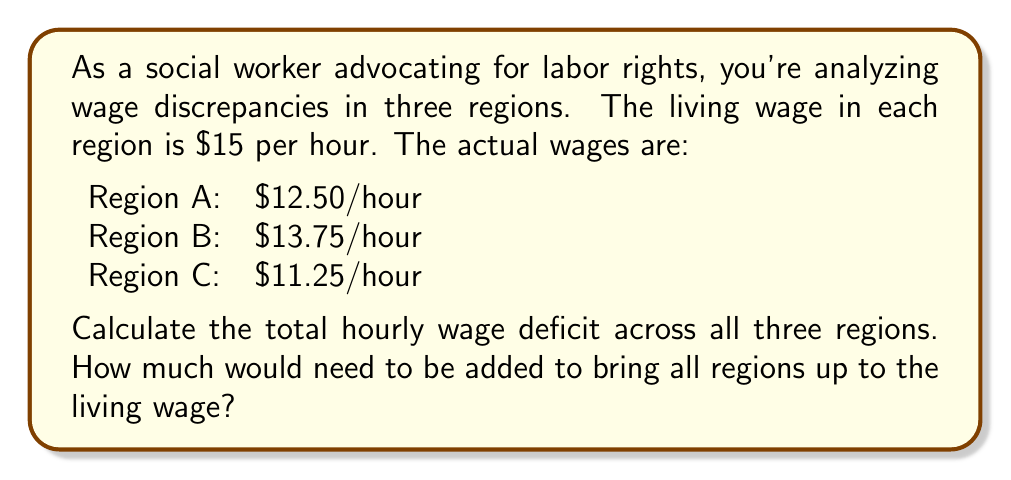Teach me how to tackle this problem. To solve this problem, we need to:
1. Calculate the wage deficit for each region
2. Sum up the deficits to get the total hourly wage deficit

Let's go through each step:

1. Calculating wage deficits:
   Region A: $15 - $12.50 = $2.50/hour
   Region B: $15 - $13.75 = $1.25/hour
   Region C: $15 - $11.25 = $3.75/hour

2. Summing up the deficits:
   Total deficit = Deficit A + Deficit B + Deficit C
   $$ \text{Total deficit} = $2.50 + $1.25 + $3.75 $$
   $$ \text{Total deficit} = $7.50 \text{ per hour} $$

Therefore, $7.50 per hour would need to be added across all three regions to bring wages up to the living wage standard.
Answer: $7.50 per hour 